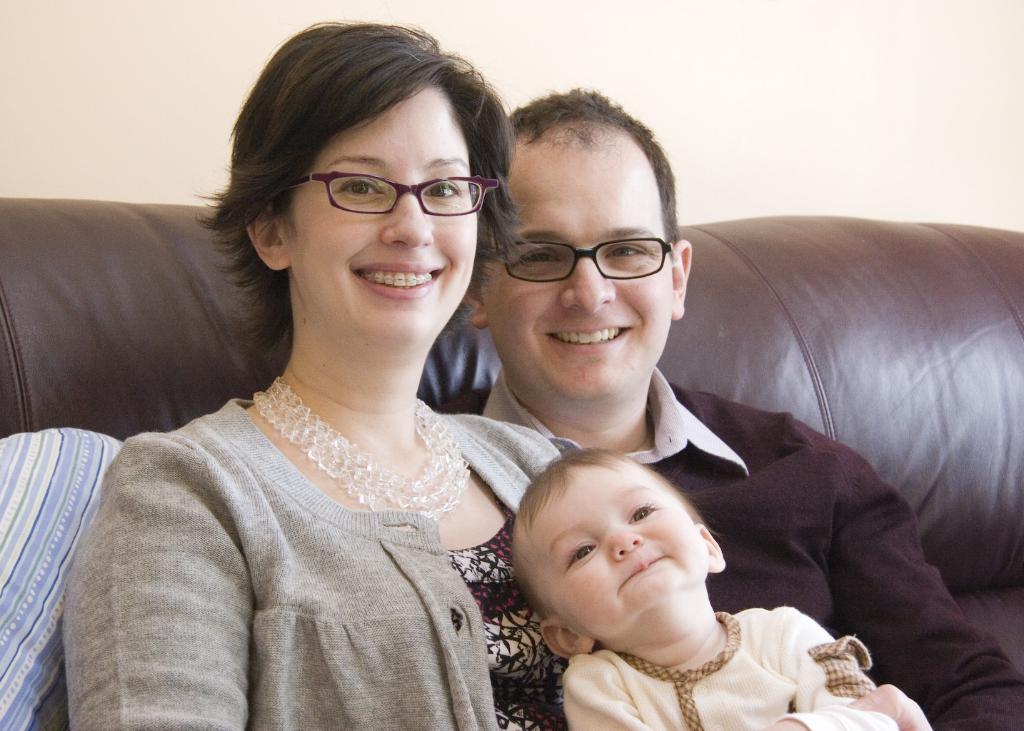Describe this image in one or two sentences. In this picture we can see a man,, woman and a kid, they both are smiling and they wore spectacles, and they are seated on the sofa. 